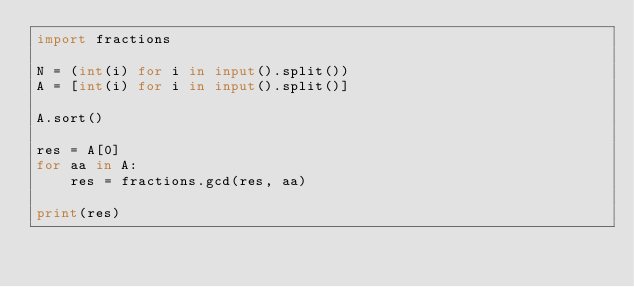<code> <loc_0><loc_0><loc_500><loc_500><_Python_>import fractions

N = (int(i) for i in input().split()) 
A = [int(i) for i in input().split()] 

A.sort()

res = A[0]
for aa in A:
    res = fractions.gcd(res, aa)

print(res)</code> 